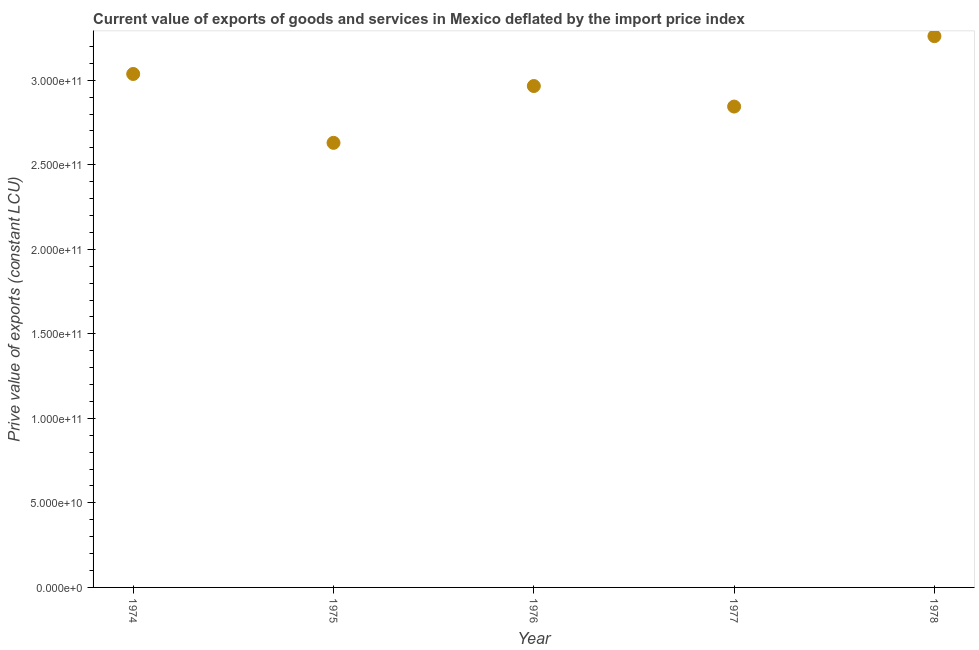What is the price value of exports in 1976?
Ensure brevity in your answer.  2.97e+11. Across all years, what is the maximum price value of exports?
Offer a terse response. 3.26e+11. Across all years, what is the minimum price value of exports?
Give a very brief answer. 2.63e+11. In which year was the price value of exports maximum?
Offer a terse response. 1978. In which year was the price value of exports minimum?
Give a very brief answer. 1975. What is the sum of the price value of exports?
Offer a terse response. 1.47e+12. What is the difference between the price value of exports in 1974 and 1978?
Offer a terse response. -2.24e+1. What is the average price value of exports per year?
Give a very brief answer. 2.95e+11. What is the median price value of exports?
Provide a short and direct response. 2.97e+11. What is the ratio of the price value of exports in 1974 to that in 1975?
Provide a short and direct response. 1.15. What is the difference between the highest and the second highest price value of exports?
Keep it short and to the point. 2.24e+1. What is the difference between the highest and the lowest price value of exports?
Ensure brevity in your answer.  6.31e+1. In how many years, is the price value of exports greater than the average price value of exports taken over all years?
Provide a short and direct response. 3. How many years are there in the graph?
Give a very brief answer. 5. What is the difference between two consecutive major ticks on the Y-axis?
Your answer should be compact. 5.00e+1. Does the graph contain grids?
Make the answer very short. No. What is the title of the graph?
Give a very brief answer. Current value of exports of goods and services in Mexico deflated by the import price index. What is the label or title of the X-axis?
Your response must be concise. Year. What is the label or title of the Y-axis?
Your response must be concise. Prive value of exports (constant LCU). What is the Prive value of exports (constant LCU) in 1974?
Your answer should be compact. 3.04e+11. What is the Prive value of exports (constant LCU) in 1975?
Provide a succinct answer. 2.63e+11. What is the Prive value of exports (constant LCU) in 1976?
Offer a terse response. 2.97e+11. What is the Prive value of exports (constant LCU) in 1977?
Provide a succinct answer. 2.84e+11. What is the Prive value of exports (constant LCU) in 1978?
Provide a short and direct response. 3.26e+11. What is the difference between the Prive value of exports (constant LCU) in 1974 and 1975?
Your answer should be very brief. 4.07e+1. What is the difference between the Prive value of exports (constant LCU) in 1974 and 1976?
Your answer should be compact. 7.13e+09. What is the difference between the Prive value of exports (constant LCU) in 1974 and 1977?
Your answer should be very brief. 1.93e+1. What is the difference between the Prive value of exports (constant LCU) in 1974 and 1978?
Make the answer very short. -2.24e+1. What is the difference between the Prive value of exports (constant LCU) in 1975 and 1976?
Provide a succinct answer. -3.36e+1. What is the difference between the Prive value of exports (constant LCU) in 1975 and 1977?
Offer a very short reply. -2.15e+1. What is the difference between the Prive value of exports (constant LCU) in 1975 and 1978?
Offer a very short reply. -6.31e+1. What is the difference between the Prive value of exports (constant LCU) in 1976 and 1977?
Your response must be concise. 1.21e+1. What is the difference between the Prive value of exports (constant LCU) in 1976 and 1978?
Keep it short and to the point. -2.95e+1. What is the difference between the Prive value of exports (constant LCU) in 1977 and 1978?
Your response must be concise. -4.16e+1. What is the ratio of the Prive value of exports (constant LCU) in 1974 to that in 1975?
Provide a short and direct response. 1.16. What is the ratio of the Prive value of exports (constant LCU) in 1974 to that in 1977?
Your answer should be compact. 1.07. What is the ratio of the Prive value of exports (constant LCU) in 1975 to that in 1976?
Your response must be concise. 0.89. What is the ratio of the Prive value of exports (constant LCU) in 1975 to that in 1977?
Ensure brevity in your answer.  0.93. What is the ratio of the Prive value of exports (constant LCU) in 1975 to that in 1978?
Provide a succinct answer. 0.81. What is the ratio of the Prive value of exports (constant LCU) in 1976 to that in 1977?
Give a very brief answer. 1.04. What is the ratio of the Prive value of exports (constant LCU) in 1976 to that in 1978?
Make the answer very short. 0.91. What is the ratio of the Prive value of exports (constant LCU) in 1977 to that in 1978?
Provide a short and direct response. 0.87. 